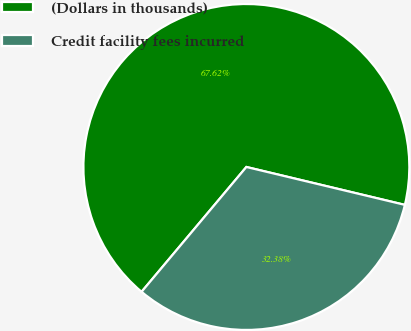Convert chart. <chart><loc_0><loc_0><loc_500><loc_500><pie_chart><fcel>(Dollars in thousands)<fcel>Credit facility fees incurred<nl><fcel>67.62%<fcel>32.38%<nl></chart> 